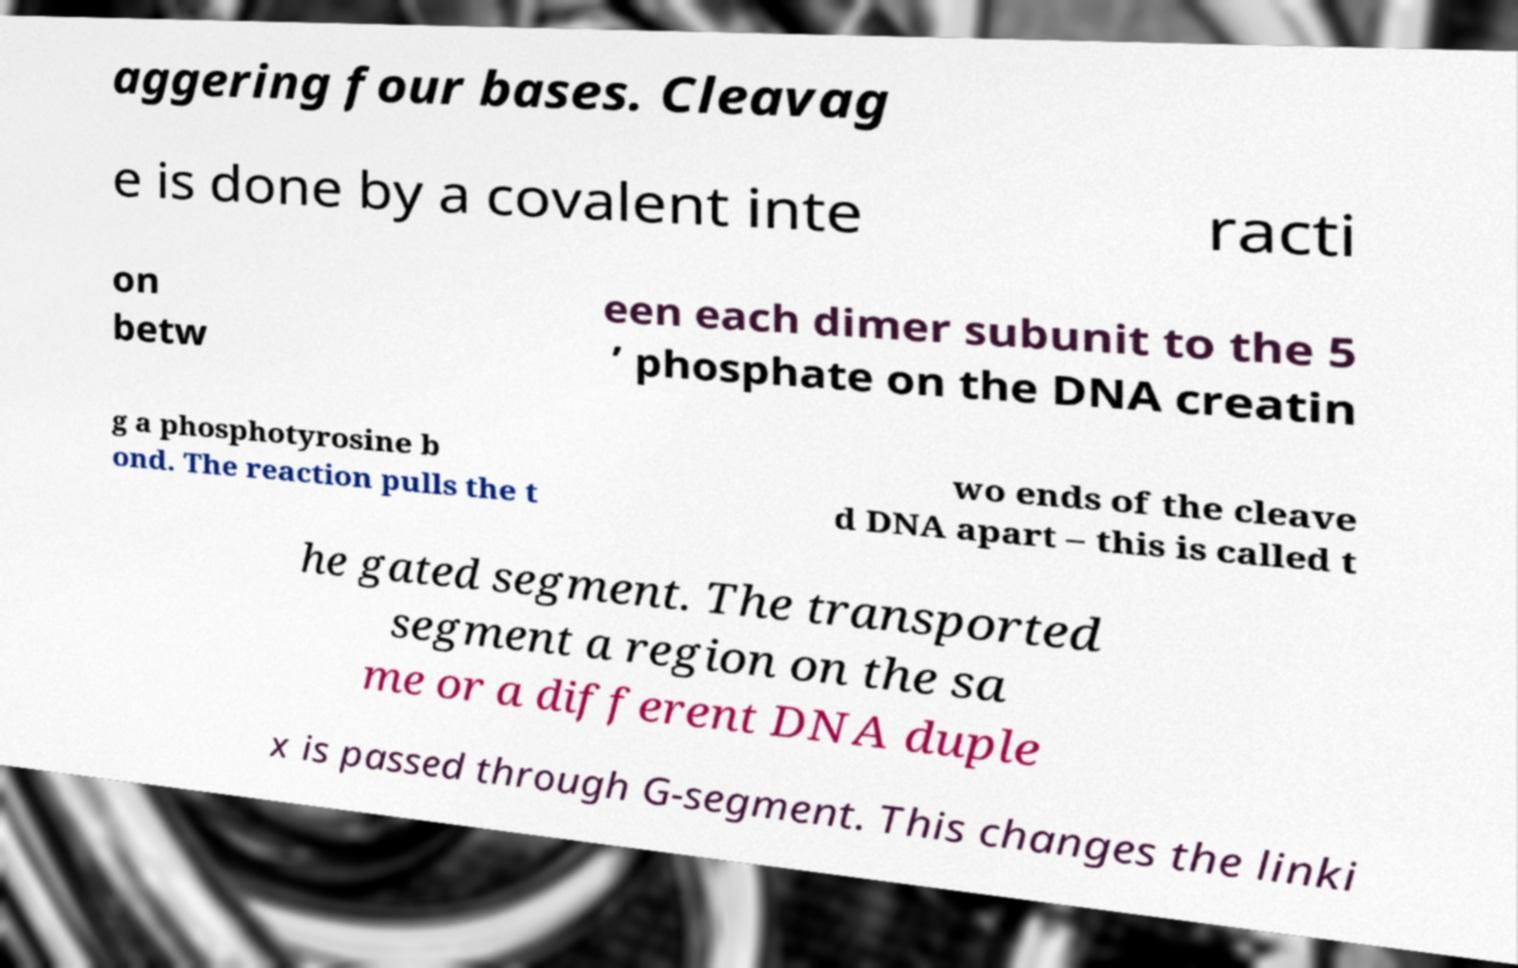Can you read and provide the text displayed in the image?This photo seems to have some interesting text. Can you extract and type it out for me? aggering four bases. Cleavag e is done by a covalent inte racti on betw een each dimer subunit to the 5 ’ phosphate on the DNA creatin g a phosphotyrosine b ond. The reaction pulls the t wo ends of the cleave d DNA apart – this is called t he gated segment. The transported segment a region on the sa me or a different DNA duple x is passed through G-segment. This changes the linki 